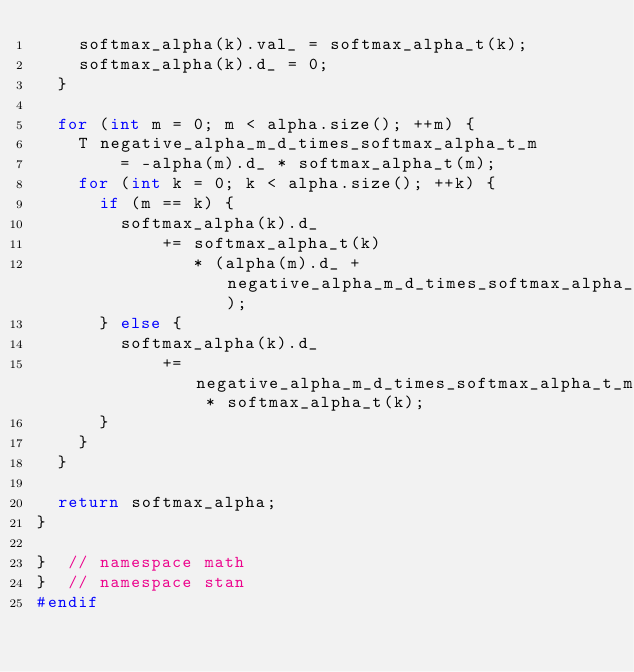Convert code to text. <code><loc_0><loc_0><loc_500><loc_500><_C++_>    softmax_alpha(k).val_ = softmax_alpha_t(k);
    softmax_alpha(k).d_ = 0;
  }

  for (int m = 0; m < alpha.size(); ++m) {
    T negative_alpha_m_d_times_softmax_alpha_t_m
        = -alpha(m).d_ * softmax_alpha_t(m);
    for (int k = 0; k < alpha.size(); ++k) {
      if (m == k) {
        softmax_alpha(k).d_
            += softmax_alpha_t(k)
               * (alpha(m).d_ + negative_alpha_m_d_times_softmax_alpha_t_m);
      } else {
        softmax_alpha(k).d_
            += negative_alpha_m_d_times_softmax_alpha_t_m * softmax_alpha_t(k);
      }
    }
  }

  return softmax_alpha;
}

}  // namespace math
}  // namespace stan
#endif
</code> 